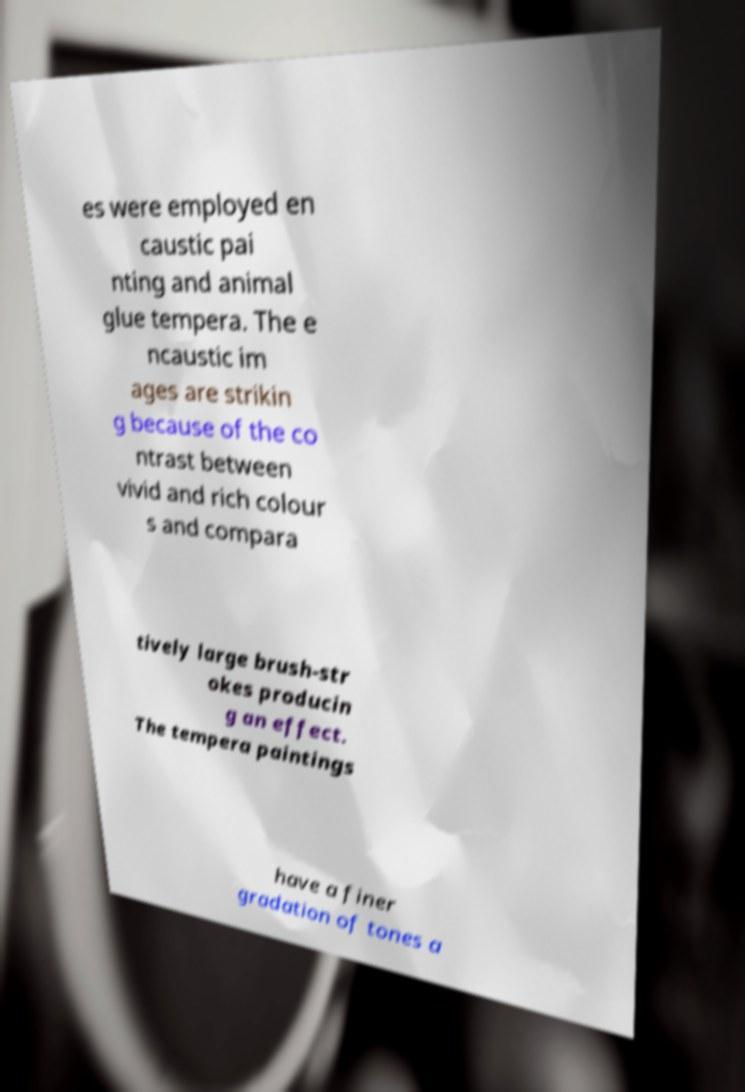Can you read and provide the text displayed in the image?This photo seems to have some interesting text. Can you extract and type it out for me? es were employed en caustic pai nting and animal glue tempera. The e ncaustic im ages are strikin g because of the co ntrast between vivid and rich colour s and compara tively large brush-str okes producin g an effect. The tempera paintings have a finer gradation of tones a 